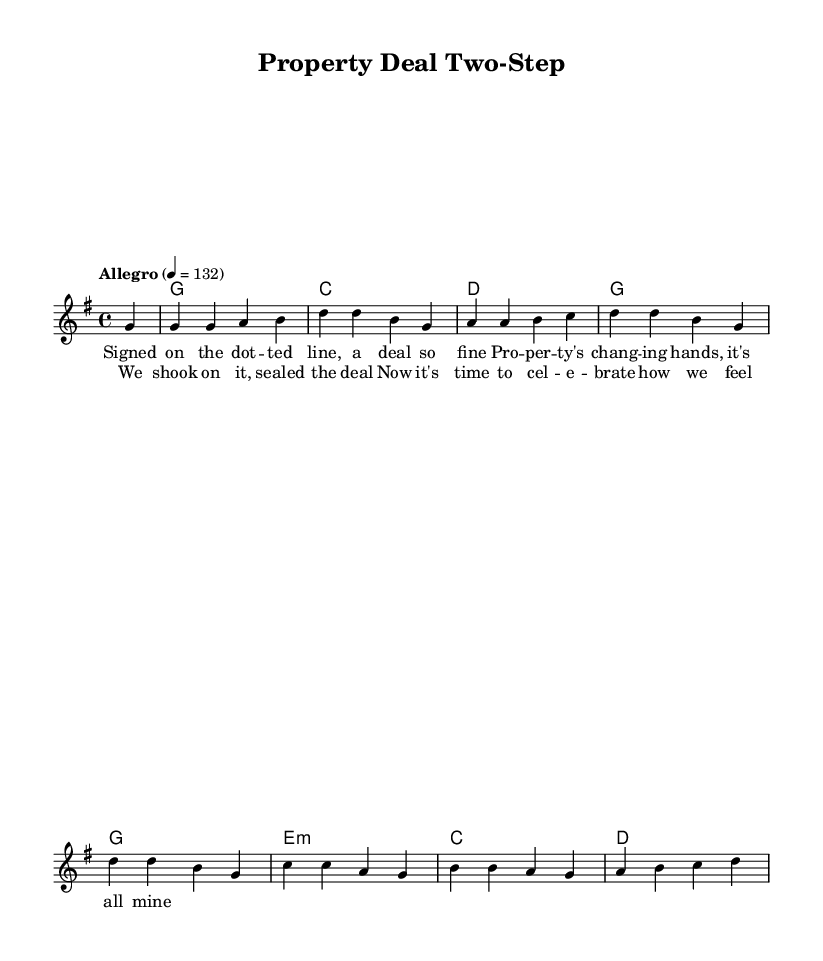What is the key signature of this music? The key signature is G major, indicated by one sharp (F#) at the beginning of the staff.
Answer: G major What is the time signature of this piece? The time signature is 4/4, as shown by the time notation at the beginning of the music.
Answer: 4/4 What is the tempo marking for this song? The tempo marking is "Allegro," indicating a fast and lively pace, with 132 beats per minute as specified.
Answer: Allegro How many measures are in the melody? By counting the segments divided by vertical lines, there are eight measures in the melody.
Answer: Eight In what key do the harmonies primarily change? The harmonies change primarily in G major, with the first chord being G major and progressing through C and D major.
Answer: G major What is the repeated structure in the chorus lyrics? The repeated structure involves celebrating the completion of the property deal, encompassing feelings of happiness and fulfillment.
Answer: Celebrating What type of song structure is represented in this piece? This piece utilizes a verse-chorus structure commonly found in country rock songs, alternating between narrative lyrics and a celebratory refrain.
Answer: Verse-chorus 